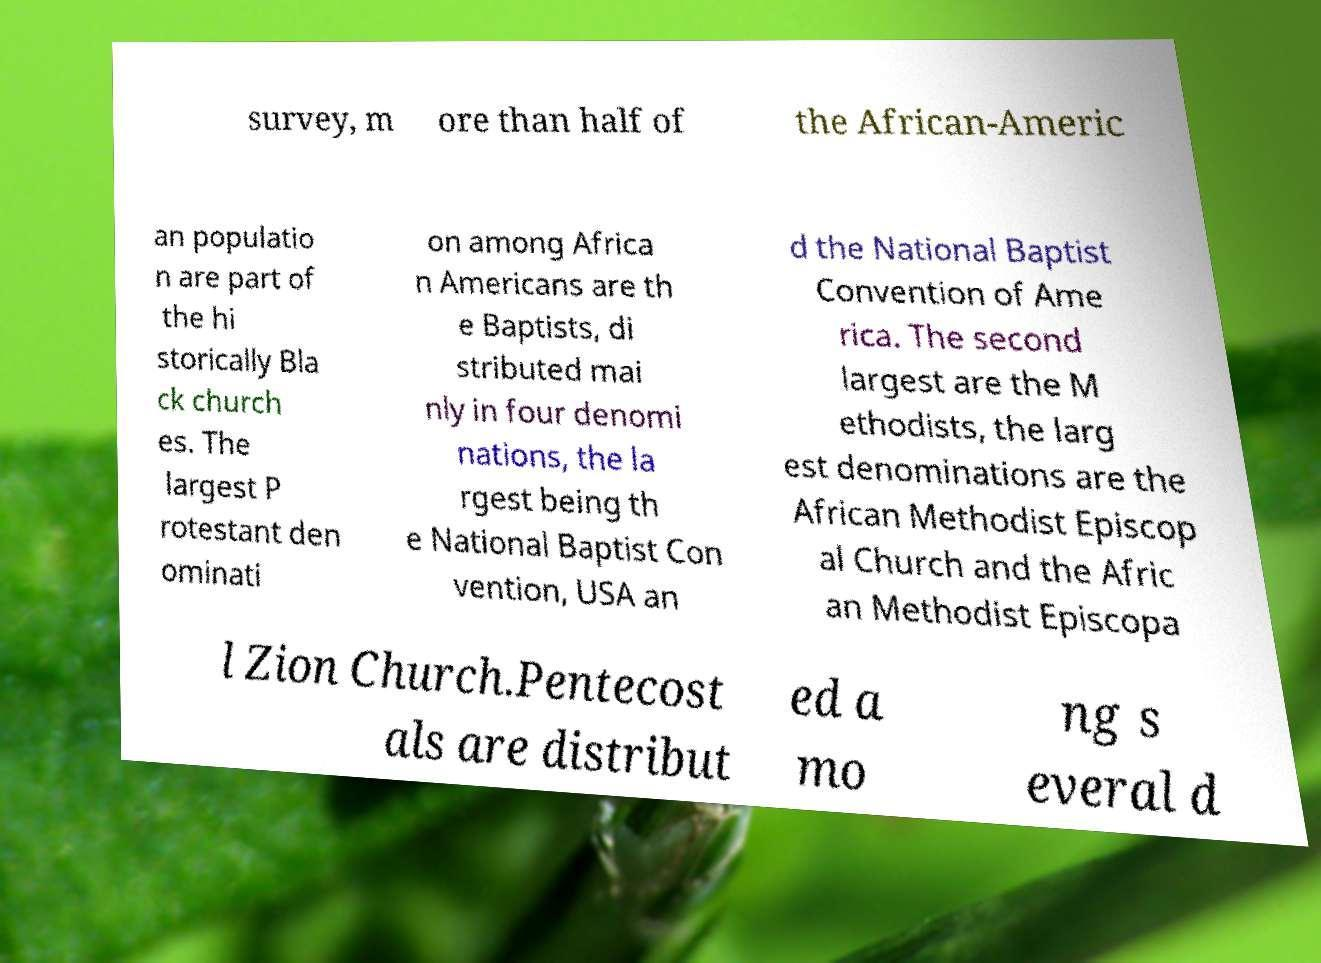Please read and relay the text visible in this image. What does it say? survey, m ore than half of the African-Americ an populatio n are part of the hi storically Bla ck church es. The largest P rotestant den ominati on among Africa n Americans are th e Baptists, di stributed mai nly in four denomi nations, the la rgest being th e National Baptist Con vention, USA an d the National Baptist Convention of Ame rica. The second largest are the M ethodists, the larg est denominations are the African Methodist Episcop al Church and the Afric an Methodist Episcopa l Zion Church.Pentecost als are distribut ed a mo ng s everal d 